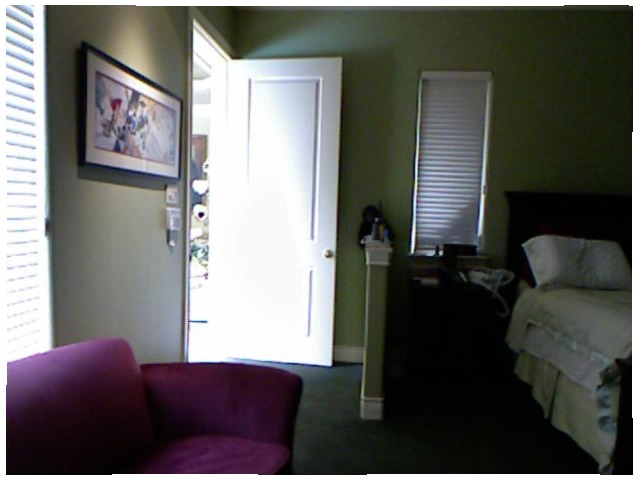<image>
Can you confirm if the door is to the left of the window? Yes. From this viewpoint, the door is positioned to the left side relative to the window. Where is the door in relation to the curtain? Is it next to the curtain? Yes. The door is positioned adjacent to the curtain, located nearby in the same general area. 